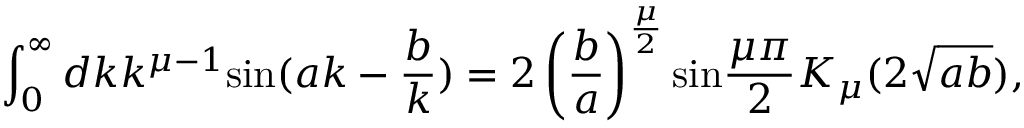Convert formula to latex. <formula><loc_0><loc_0><loc_500><loc_500>\int _ { 0 } ^ { \infty } d k k ^ { { \mu } - 1 } \sin ( a k - \frac { b } { k } ) = 2 \left ( \frac { b } { a } \right ) ^ { \frac { \mu } { 2 } } \sin \frac { { \mu } { \pi } } { 2 } K _ { \mu } ( 2 \sqrt { a b } ) ,</formula> 